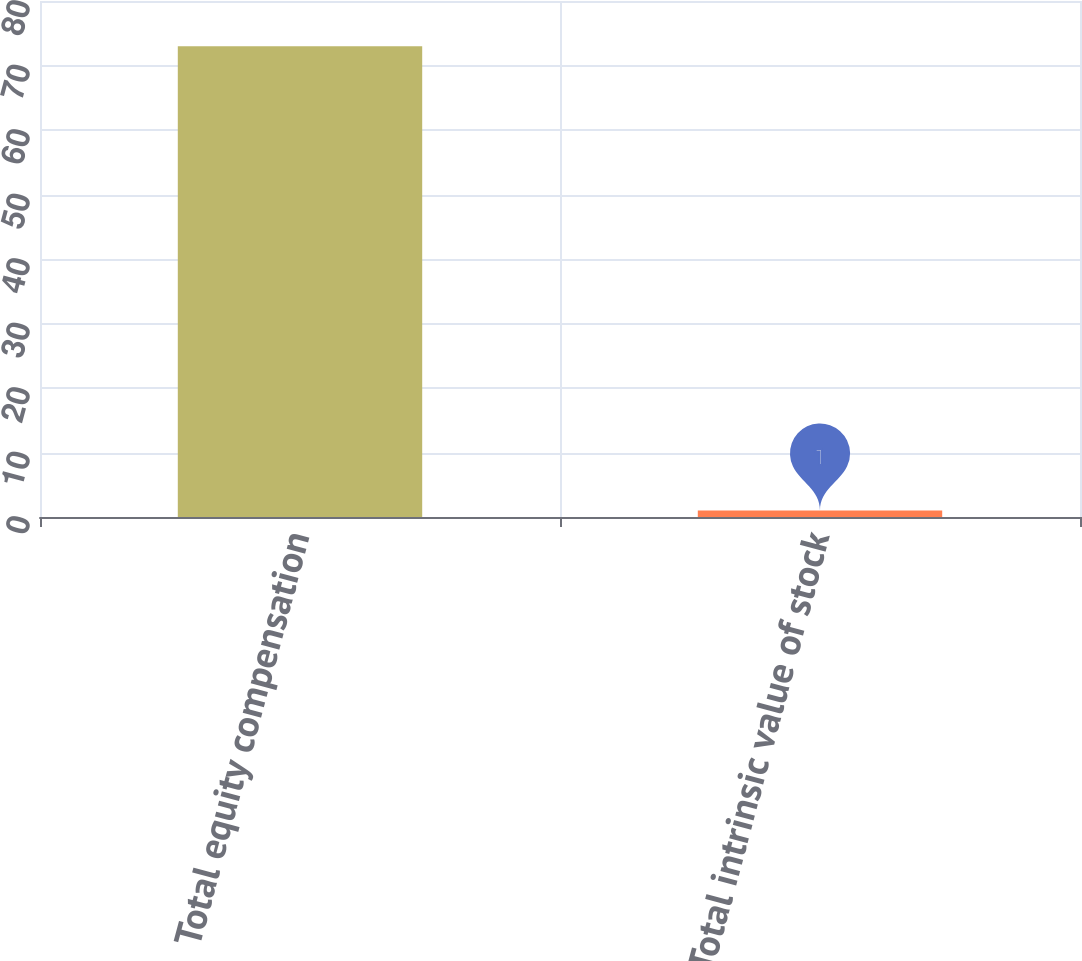Convert chart to OTSL. <chart><loc_0><loc_0><loc_500><loc_500><bar_chart><fcel>Total equity compensation<fcel>Total intrinsic value of stock<nl><fcel>73<fcel>1<nl></chart> 